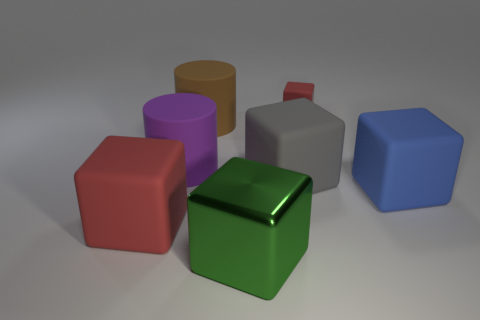Add 3 big purple shiny spheres. How many objects exist? 10 Subtract all small cubes. How many cubes are left? 4 Subtract all red cubes. How many cubes are left? 3 Subtract all cylinders. How many objects are left? 5 Subtract all cyan cylinders. How many red cubes are left? 2 Subtract 2 cylinders. How many cylinders are left? 0 Subtract all large red rubber balls. Subtract all cylinders. How many objects are left? 5 Add 3 large red things. How many large red things are left? 4 Add 6 large green metallic things. How many large green metallic things exist? 7 Subtract 1 green blocks. How many objects are left? 6 